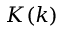<formula> <loc_0><loc_0><loc_500><loc_500>K ( k )</formula> 